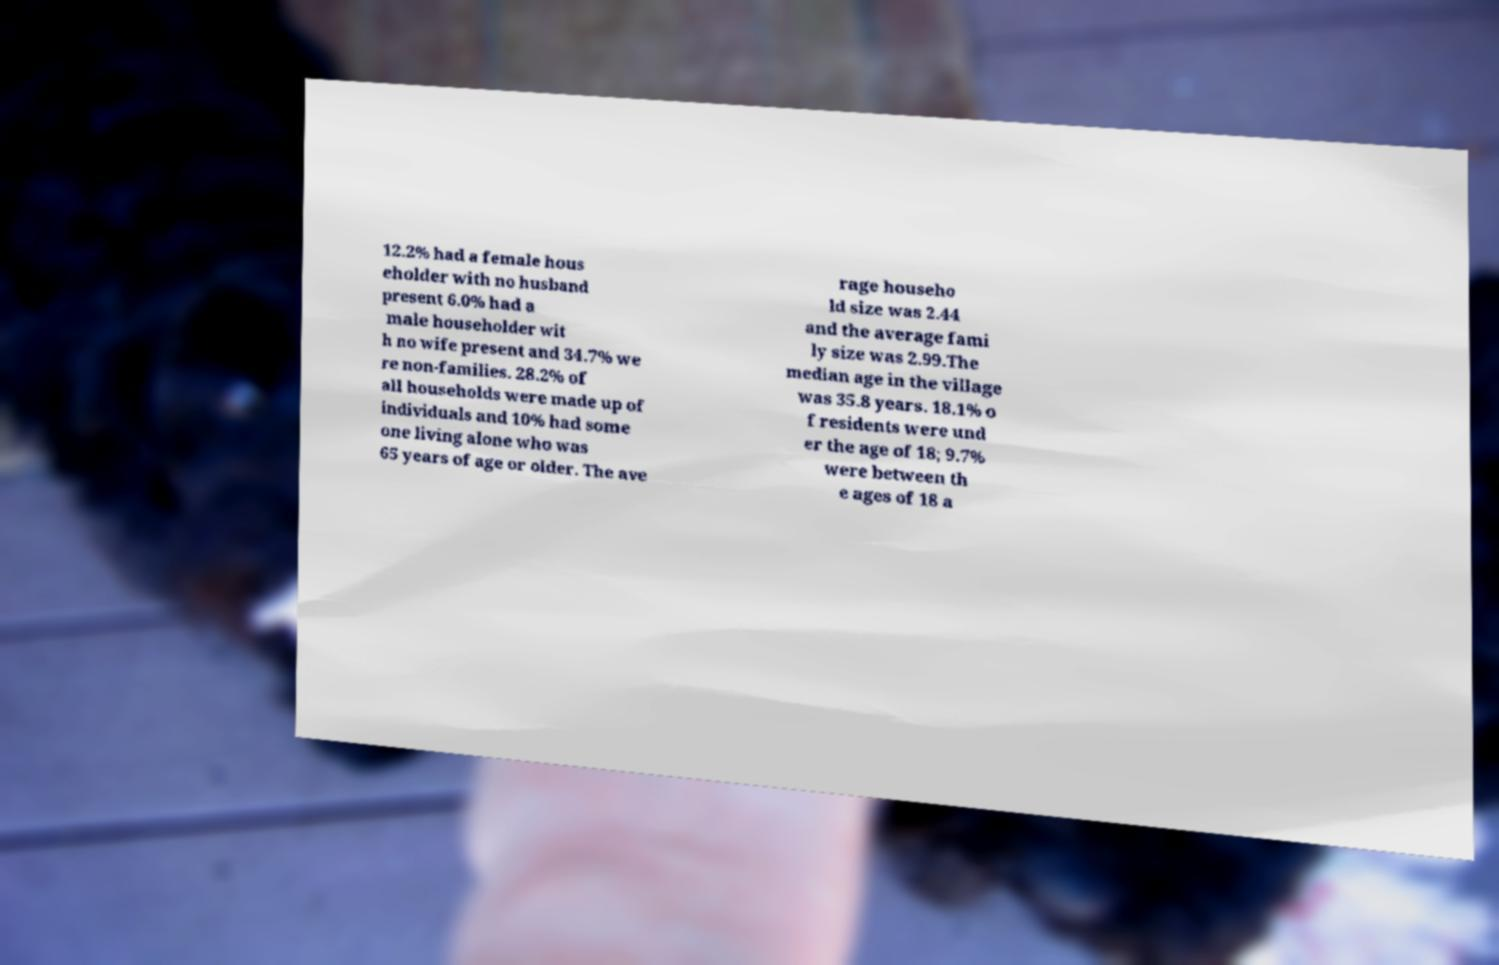Please identify and transcribe the text found in this image. 12.2% had a female hous eholder with no husband present 6.0% had a male householder wit h no wife present and 34.7% we re non-families. 28.2% of all households were made up of individuals and 10% had some one living alone who was 65 years of age or older. The ave rage househo ld size was 2.44 and the average fami ly size was 2.99.The median age in the village was 35.8 years. 18.1% o f residents were und er the age of 18; 9.7% were between th e ages of 18 a 